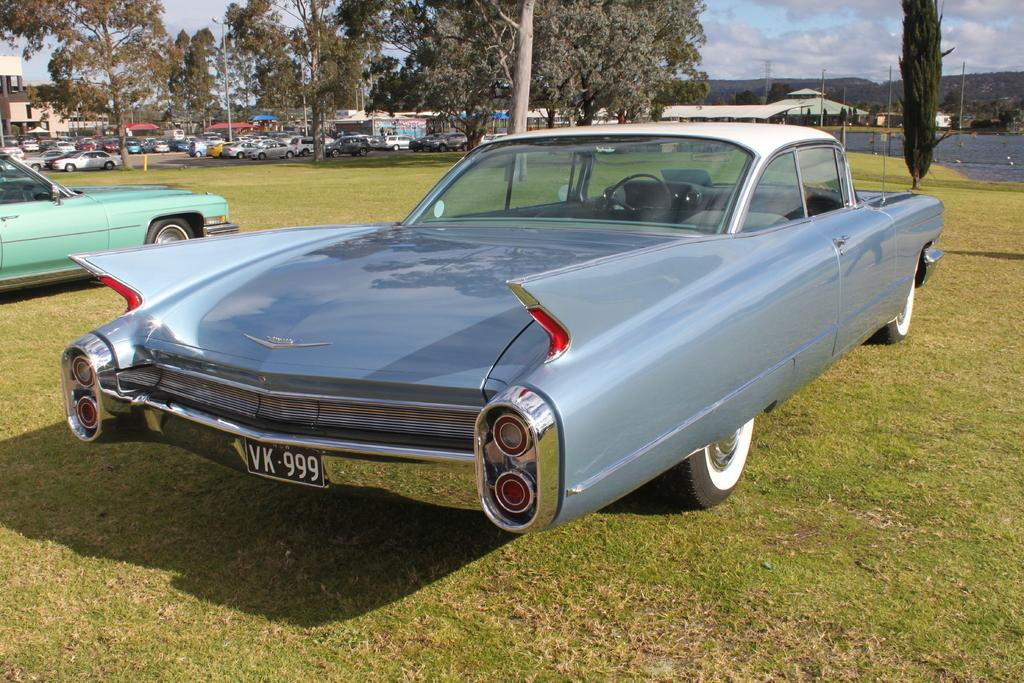What can be seen on the ground in the image? There are vehicles parked on the ground in the image. What is visible in the background of the image? There is a group of trees, buildings, poles, water, and the sky visible in the background of the image. How many dimes are scattered on the ground in the image? There are no dimes visible on the ground in the image. What type of calendar is hanging on the wall in the image? There is no calendar present in the image. Can you see a pig in the image? There is no pig present in the image. 